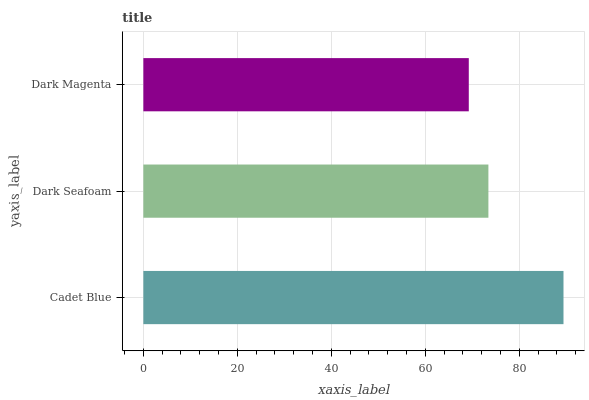Is Dark Magenta the minimum?
Answer yes or no. Yes. Is Cadet Blue the maximum?
Answer yes or no. Yes. Is Dark Seafoam the minimum?
Answer yes or no. No. Is Dark Seafoam the maximum?
Answer yes or no. No. Is Cadet Blue greater than Dark Seafoam?
Answer yes or no. Yes. Is Dark Seafoam less than Cadet Blue?
Answer yes or no. Yes. Is Dark Seafoam greater than Cadet Blue?
Answer yes or no. No. Is Cadet Blue less than Dark Seafoam?
Answer yes or no. No. Is Dark Seafoam the high median?
Answer yes or no. Yes. Is Dark Seafoam the low median?
Answer yes or no. Yes. Is Cadet Blue the high median?
Answer yes or no. No. Is Dark Magenta the low median?
Answer yes or no. No. 